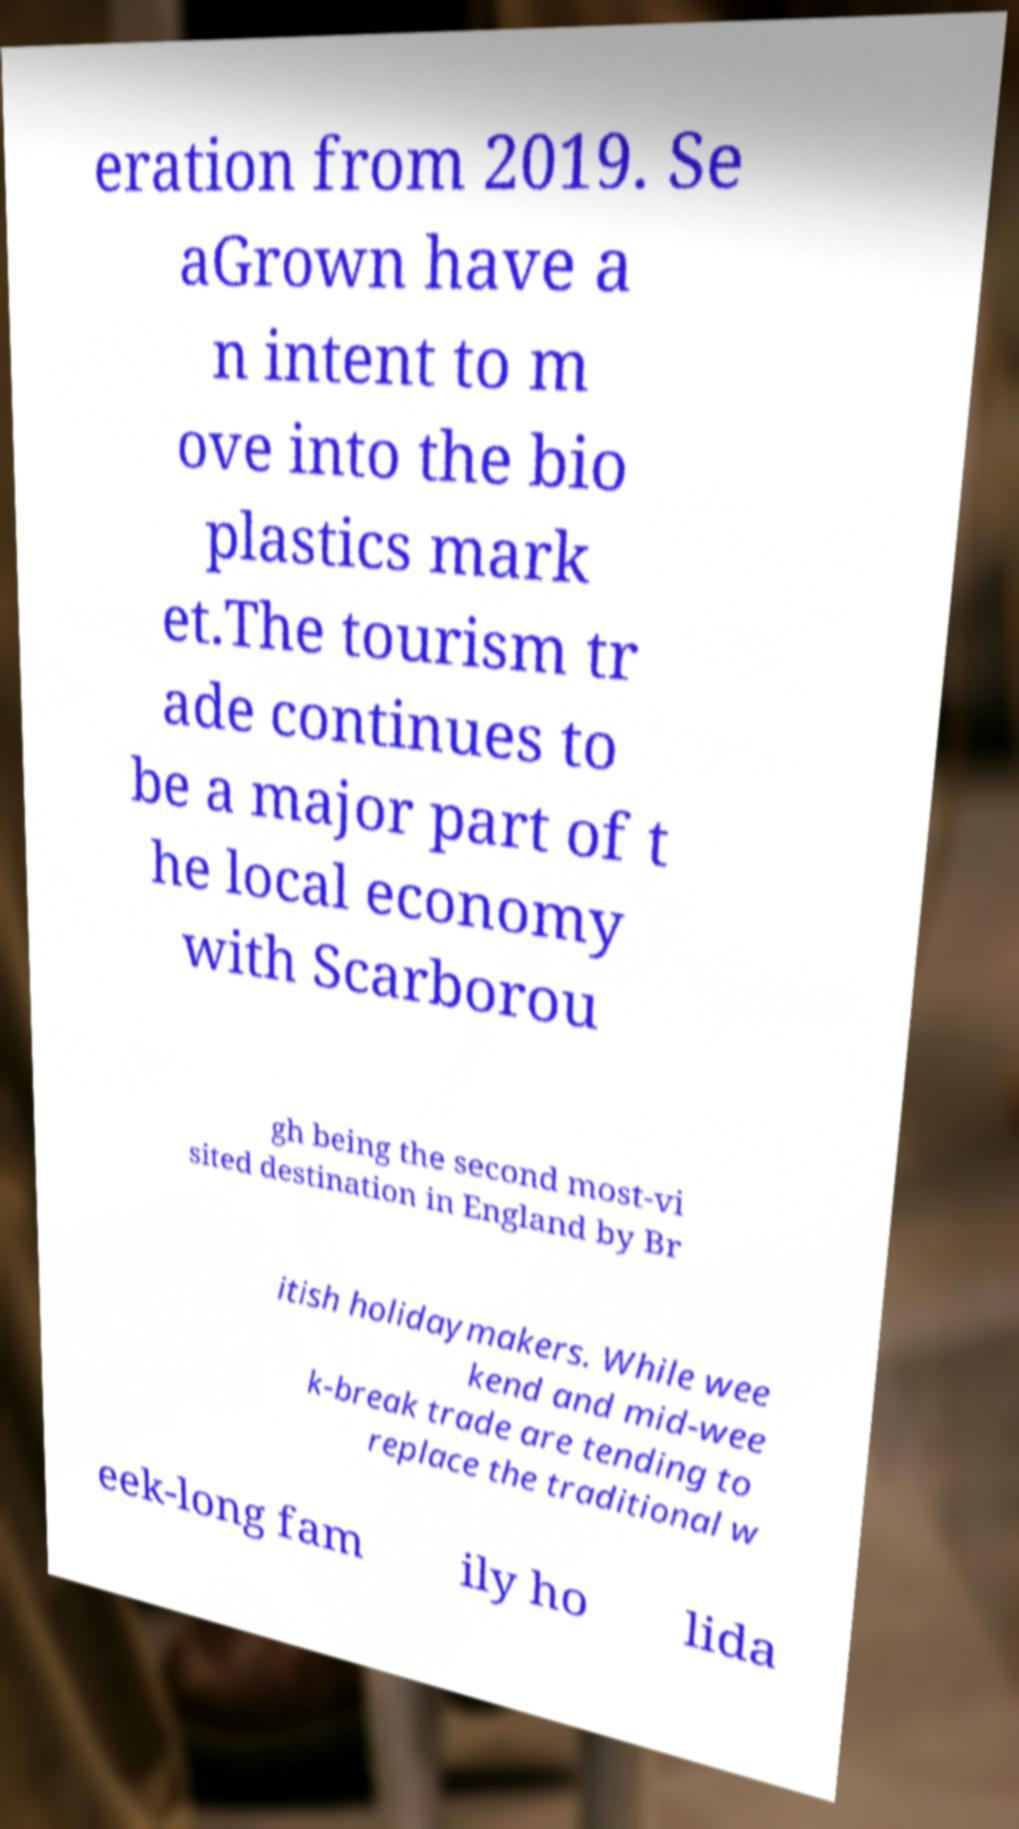For documentation purposes, I need the text within this image transcribed. Could you provide that? eration from 2019. Se aGrown have a n intent to m ove into the bio plastics mark et.The tourism tr ade continues to be a major part of t he local economy with Scarborou gh being the second most-vi sited destination in England by Br itish holidaymakers. While wee kend and mid-wee k-break trade are tending to replace the traditional w eek-long fam ily ho lida 